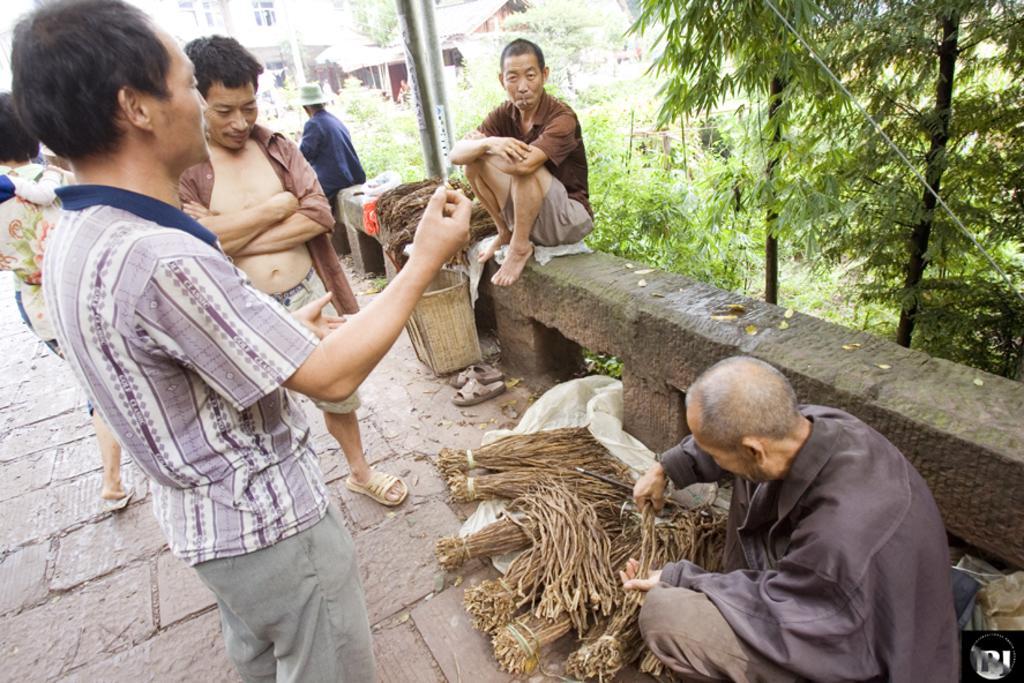In one or two sentences, can you explain what this image depicts? In this image, there is an outside view. There are two persons on the left side of the image standing and wearing clothes. There is a person at the top of the image sitting on the bench. There is a person in the bottom right of the image holding something with his hands. There are tree in the top right of the image. 